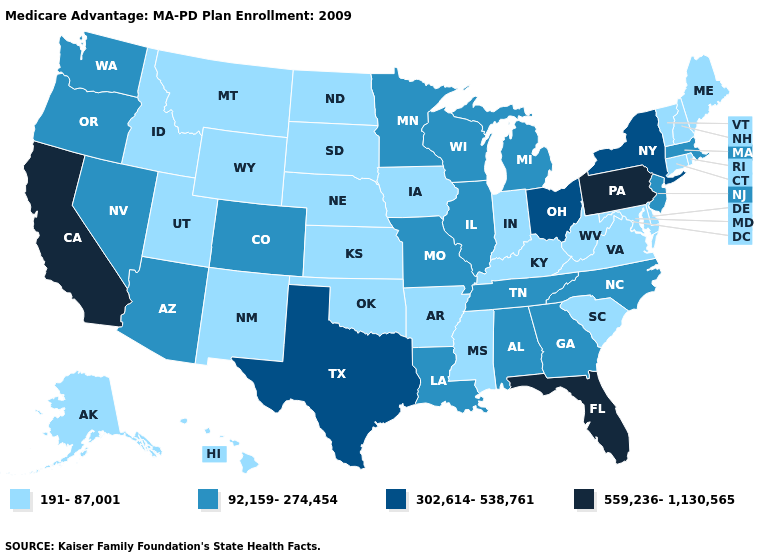Does California have the same value as Florida?
Answer briefly. Yes. Among the states that border Pennsylvania , does Ohio have the lowest value?
Write a very short answer. No. What is the highest value in states that border Virginia?
Quick response, please. 92,159-274,454. What is the value of Missouri?
Concise answer only. 92,159-274,454. What is the value of Mississippi?
Concise answer only. 191-87,001. What is the highest value in the MidWest ?
Quick response, please. 302,614-538,761. Among the states that border Kansas , which have the lowest value?
Keep it brief. Nebraska, Oklahoma. What is the value of Washington?
Concise answer only. 92,159-274,454. Does Mississippi have the lowest value in the South?
Concise answer only. Yes. What is the highest value in states that border Kansas?
Keep it brief. 92,159-274,454. Among the states that border New York , does New Jersey have the highest value?
Write a very short answer. No. Is the legend a continuous bar?
Short answer required. No. Name the states that have a value in the range 92,159-274,454?
Give a very brief answer. Alabama, Arizona, Colorado, Georgia, Illinois, Louisiana, Massachusetts, Michigan, Minnesota, Missouri, North Carolina, New Jersey, Nevada, Oregon, Tennessee, Washington, Wisconsin. Among the states that border New Jersey , which have the highest value?
Be succinct. Pennsylvania. Which states have the lowest value in the South?
Keep it brief. Arkansas, Delaware, Kentucky, Maryland, Mississippi, Oklahoma, South Carolina, Virginia, West Virginia. 